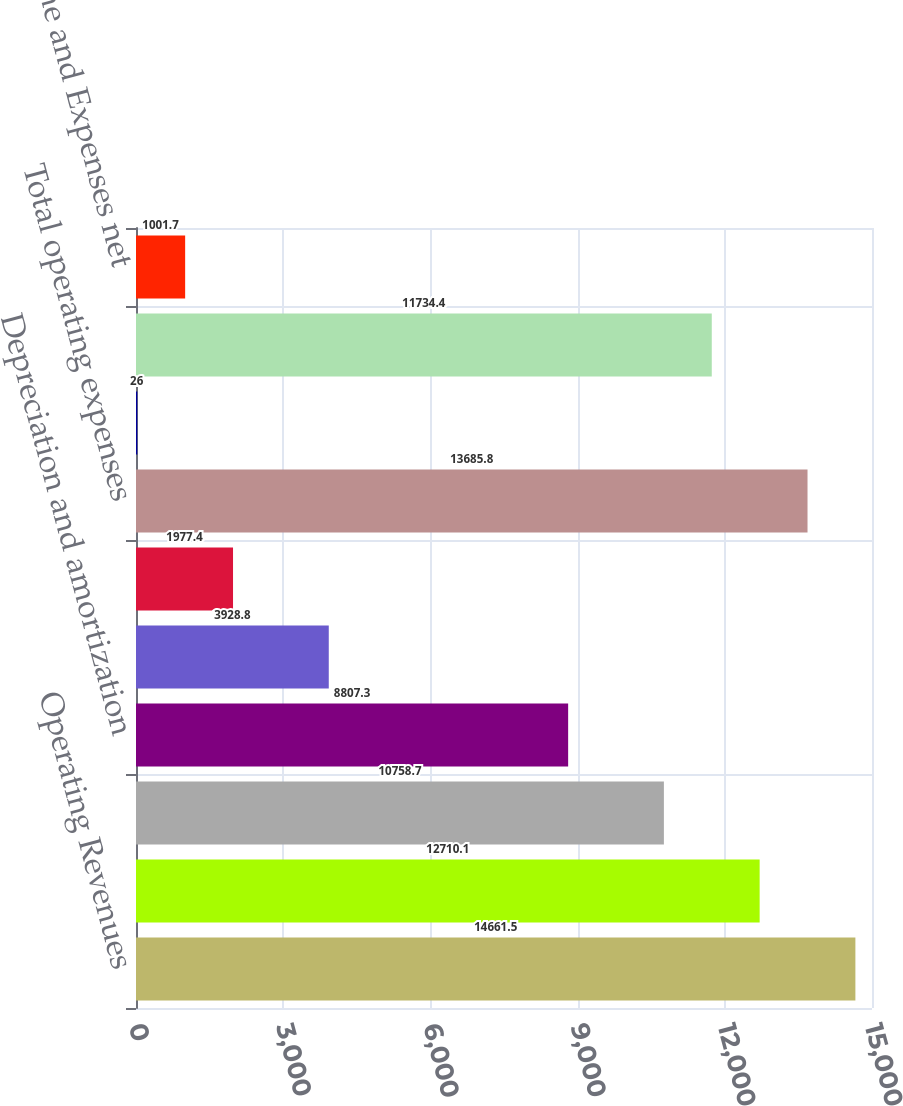Convert chart to OTSL. <chart><loc_0><loc_0><loc_500><loc_500><bar_chart><fcel>Operating Revenues<fcel>Fuel used in electric<fcel>Operation maintenance and<fcel>Depreciation and amortization<fcel>Property and other taxes<fcel>Impairment charges<fcel>Total operating expenses<fcel>Gains on Sales of Other Assets<fcel>Operating Income<fcel>Other Income and Expenses net<nl><fcel>14661.5<fcel>12710.1<fcel>10758.7<fcel>8807.3<fcel>3928.8<fcel>1977.4<fcel>13685.8<fcel>26<fcel>11734.4<fcel>1001.7<nl></chart> 